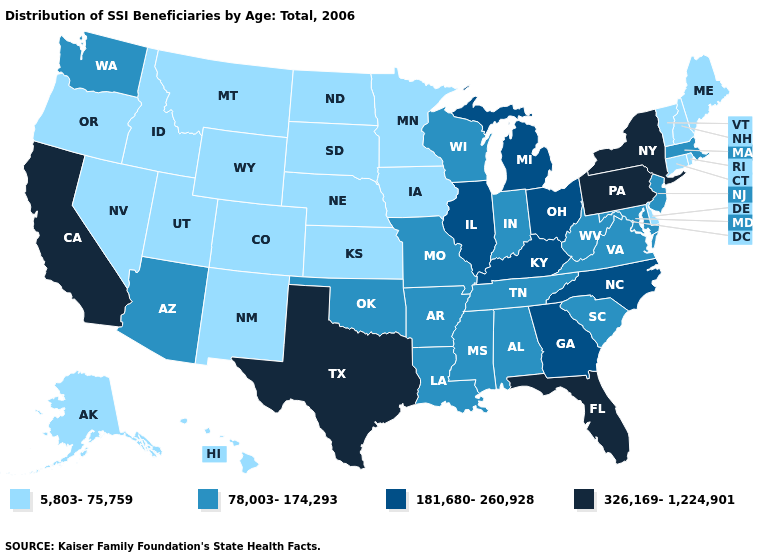Does the first symbol in the legend represent the smallest category?
Concise answer only. Yes. Does Connecticut have the same value as New Jersey?
Concise answer only. No. Which states have the lowest value in the West?
Short answer required. Alaska, Colorado, Hawaii, Idaho, Montana, Nevada, New Mexico, Oregon, Utah, Wyoming. What is the value of North Carolina?
Short answer required. 181,680-260,928. What is the value of California?
Quick response, please. 326,169-1,224,901. Does Pennsylvania have the highest value in the Northeast?
Quick response, please. Yes. Name the states that have a value in the range 78,003-174,293?
Answer briefly. Alabama, Arizona, Arkansas, Indiana, Louisiana, Maryland, Massachusetts, Mississippi, Missouri, New Jersey, Oklahoma, South Carolina, Tennessee, Virginia, Washington, West Virginia, Wisconsin. Does Nevada have the same value as Vermont?
Quick response, please. Yes. Does Pennsylvania have the highest value in the Northeast?
Write a very short answer. Yes. What is the lowest value in the Northeast?
Write a very short answer. 5,803-75,759. Does Illinois have the same value as North Carolina?
Answer briefly. Yes. Is the legend a continuous bar?
Be succinct. No. Name the states that have a value in the range 78,003-174,293?
Quick response, please. Alabama, Arizona, Arkansas, Indiana, Louisiana, Maryland, Massachusetts, Mississippi, Missouri, New Jersey, Oklahoma, South Carolina, Tennessee, Virginia, Washington, West Virginia, Wisconsin. What is the value of South Dakota?
Keep it brief. 5,803-75,759. What is the highest value in states that border Nevada?
Answer briefly. 326,169-1,224,901. 